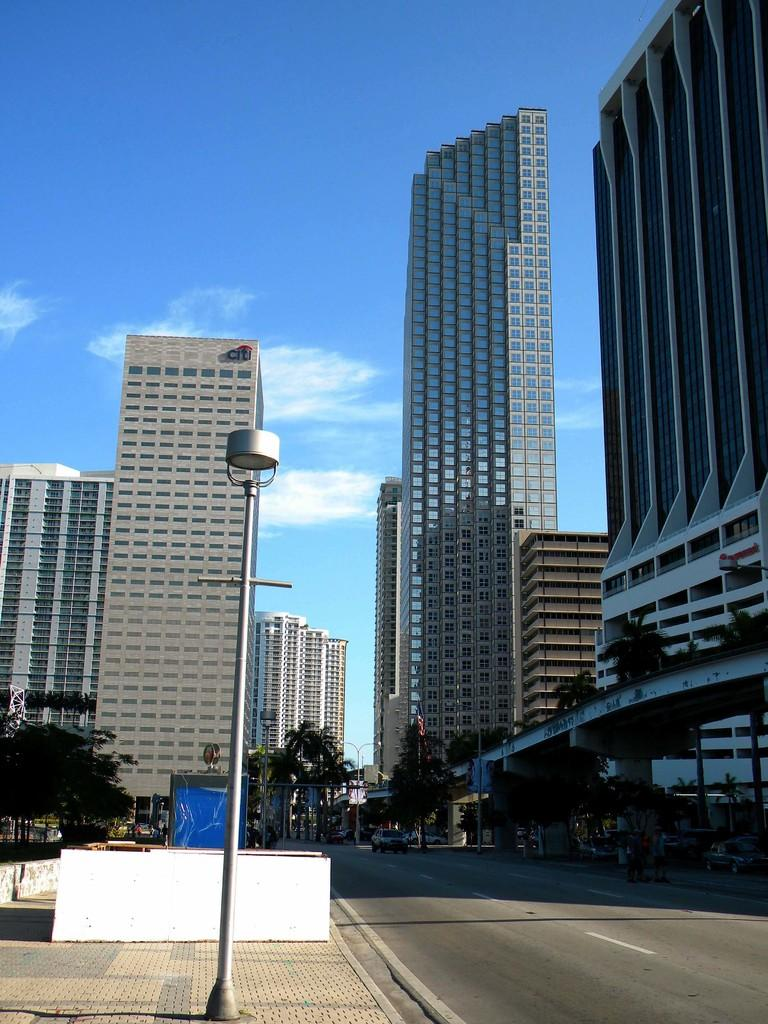What structures are present in the image? There are poles, trees, and buildings in the image. What type of vehicle can be seen on the road in the image? There is a car on the road in the image. What is visible in the background of the image? The sky is visible in the background of the image. What can be observed in the sky? Clouds are present in the sky. Where is the throne located in the image? There is no throne present in the image. What type of coat is being worn by the trees in the image? Trees do not wear coats; they are stationary objects in the image. 